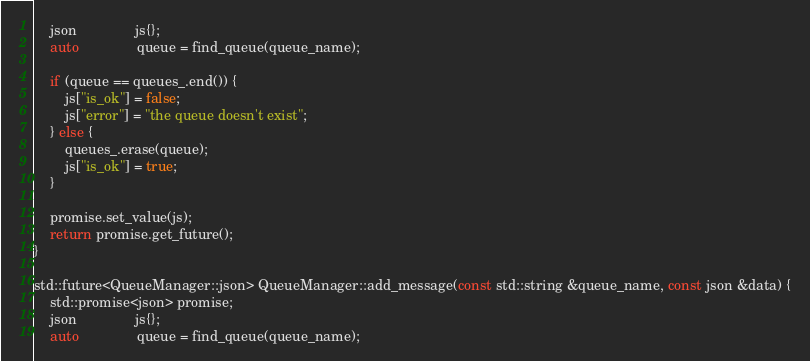<code> <loc_0><loc_0><loc_500><loc_500><_C++_>    json               js{};
    auto               queue = find_queue(queue_name);

    if (queue == queues_.end()) {
        js["is_ok"] = false;
        js["error"] = "the queue doesn't exist";
    } else {
        queues_.erase(queue);
        js["is_ok"] = true;
    }

    promise.set_value(js);
    return promise.get_future();
}

std::future<QueueManager::json> QueueManager::add_message(const std::string &queue_name, const json &data) {
    std::promise<json> promise;
    json               js{};
    auto               queue = find_queue(queue_name);
</code> 